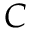<formula> <loc_0><loc_0><loc_500><loc_500>C</formula> 